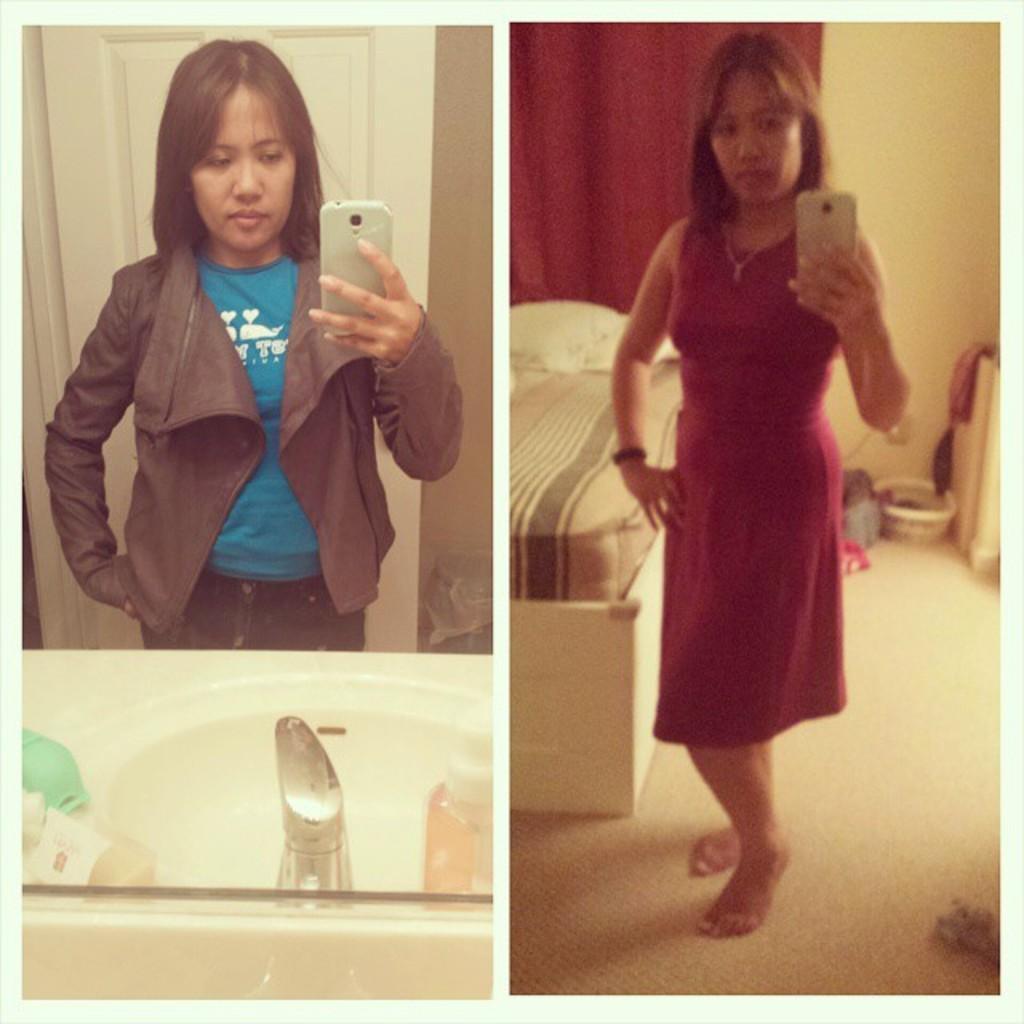In one or two sentences, can you explain what this image depicts? In the image we can see collage photos. In the collage photos we can see a woman standing, wearing clothes and holding an electronic device in hand. Here we can see basin, water tap, floor, bed and the wall. 